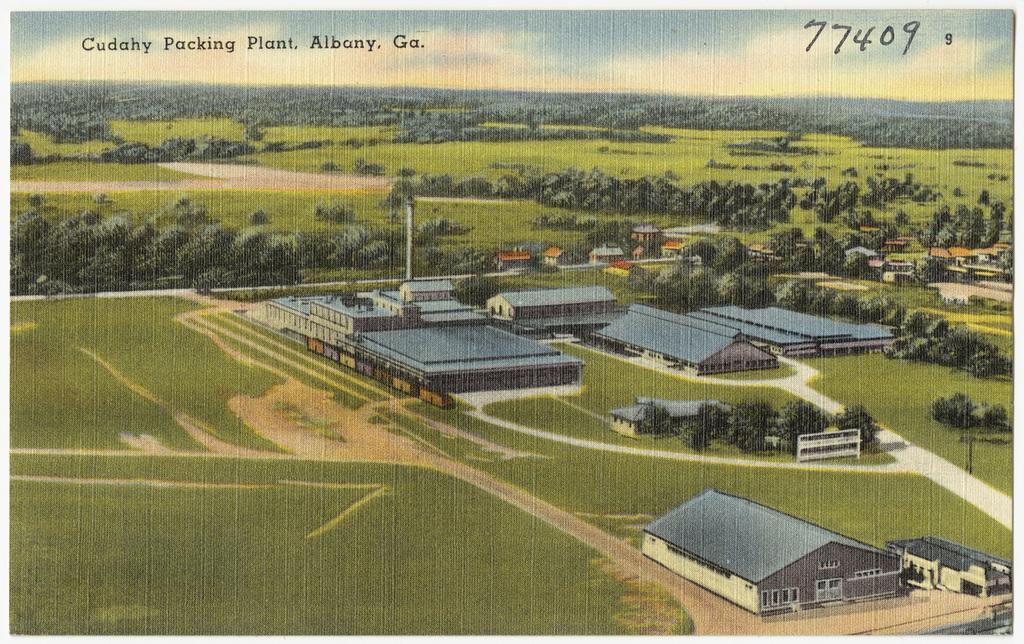Please provide a concise description of this image. This image looks like it is edited. In the front, there are houses and sheds. At the bottom, there is green grass. In the background, there are plants and trees. At the top, there is a sky. 